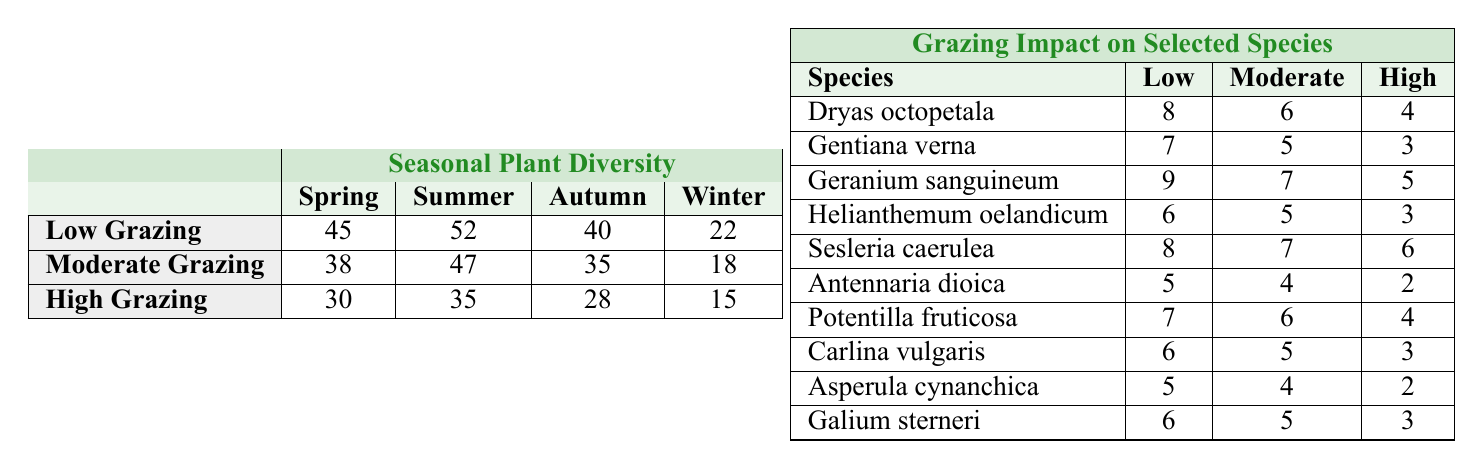What is the diversity score for low grazing in spring? The table shows that under low grazing in spring, the diversity score is 45.
Answer: 45 What is the highest diversity score recorded in summer? In the summer, the table indicates that the highest diversity score is under low grazing, which is 52.
Answer: 52 Which season has the lowest plant diversity under high grazing? The table reveals that in winter, the diversity score under high grazing is the lowest at 15.
Answer: 15 What is the difference in diversity scores between moderate grazing in spring and autumn? From the table, the diversity score for moderate grazing in spring is 38, and in autumn, it is 35. The difference is 38 - 35 = 3.
Answer: 3 Are there more species recorded under low grazing in summer compared to winter? The table shows the diversity scores for low grazing are 52 in summer and 22 in winter, indicating there are more species in summer.
Answer: Yes What is the average diversity score for high grazing across all seasons? The high grazing scores are 30 (spring), 35 (summer), 28 (autumn), and 15 (winter). Summing these gives 30 + 35 + 28 + 15 = 108, and dividing by 4 gives an average of 108/4 = 27.
Answer: 27 Which season or grazing intensity combination has the highest plant diversity? The highest plant diversity recorded is 52 under low grazing in summer, as shown in the table.
Answer: Low grazing in summer How much lower is the plant diversity score for moderate grazing in winter compared to low grazing in winter? The moderate grazing score in winter is 18, and the low grazing score in winter is 22. The difference is 22 - 18 = 4.
Answer: 4 Is the diversity score for high grazing in autumn greater than that in winter? The table shows that the diversity score for high grazing in autumn is 28 and in winter is 15, meaning the autumn score is indeed greater.
Answer: Yes What is the total diversity score for low grazing across all seasons? The scores for low grazing are 45 (spring), 52 (summer), 40 (autumn), and 22 (winter). Summing these gives 45 + 52 + 40 + 22 = 159.
Answer: 159 